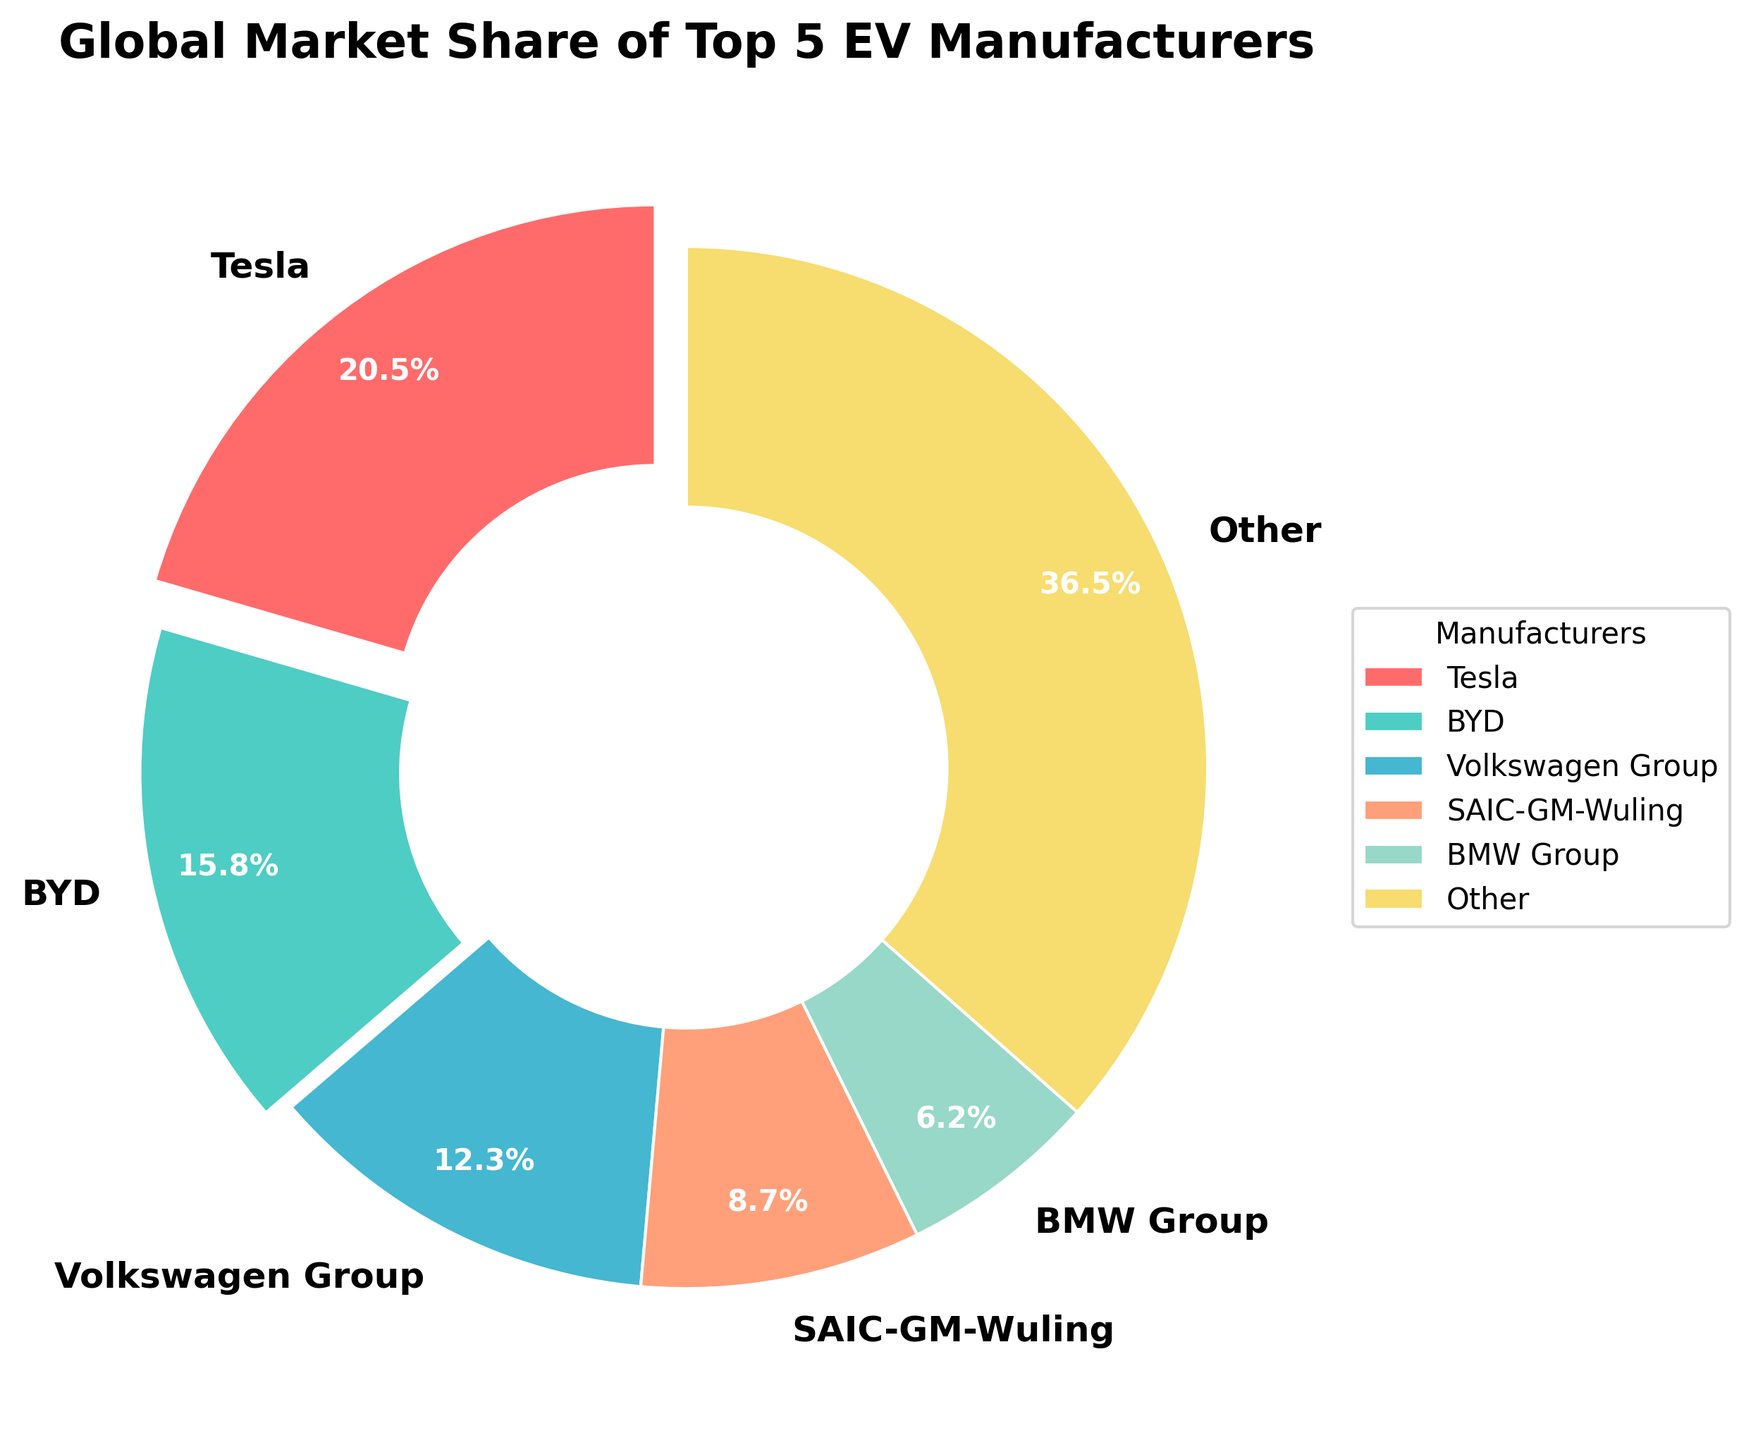What is Tesla's global market share? Tesla's market share can be read directly from the pie chart segment labeled "Tesla".
Answer: 20.5% Which manufacturer has the second largest market share? The segment with the second largest market share after Tesla is labeled "BYD".
Answer: BYD By how much does Tesla's market share exceed BMW Group's market share? Subtract BMW Group's market share from Tesla's market share: 20.5% - 6.2% = 14.3%.
Answer: 14.3% What percentage of the market do the top three manufacturers hold collectively? Sum the market shares of Tesla, BYD, and Volkswagen Group: 20.5% + 15.8% + 12.3% = 48.6%.
Answer: 48.6% Which manufacturer has the smallest market share among the top 5? The segment with the smallest market share among the top 5 manufacturers is labeled "BMW Group".
Answer: BMW Group What color represents SAIC-GM-Wuling's market share? The segment labeled "SAIC-GM-Wuling" is visually colored in a certain hue, which in this case appears as an orange-like color.
Answer: orange Are there more manufacturers with a market share greater than 10% or less than 10% among the top 5? Three manufacturers (Tesla, BYD, and Volkswagen Group) have a market share greater than 10%, while two (SAIC-GM-Wuling and BMW Group) have a market share less than 10%.
Answer: greater than 10% How much more market share does the "Other" category have compared to Volkswagen Group? Subtract Volkswagen Group's market share from the "Other" category's market share: 36.5% - 12.3% = 24.2%.
Answer: 24.2% Compared to BYD, how much larger is the market share of the "Other" category? Subtract BYD's market share from the "Other" category's market share: 36.5% - 15.8% = 20.7%.
Answer: 20.7% Is the combined market share of SAIC-GM-Wuling and BMW Group greater than Volkswagen Group's market share? Sum the market shares of SAIC-GM-Wuling and BMW Group and compare to Volkswagen Group: 8.7% + 6.2% = 14.9%, which is greater than 12.3%.
Answer: Yes 